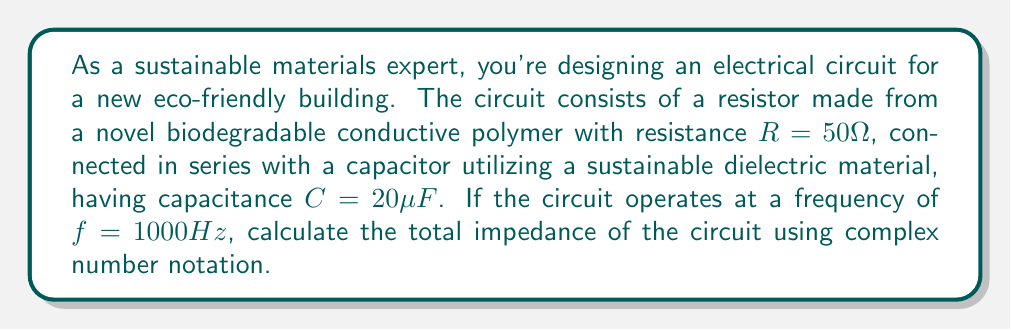Solve this math problem. To solve this problem, we'll follow these steps:

1) First, recall that impedance is a complex number that represents the total opposition to current flow in an AC circuit. It's expressed as $Z = R + jX$, where $R$ is resistance and $X$ is reactance.

2) We're given the resistance $R = 50\Omega$. This will be the real part of our impedance.

3) For the capacitor, we need to calculate its reactance. The formula for capacitive reactance is:

   $X_C = -\frac{1}{2\pi fC}$

4) Let's substitute our values:
   $f = 1000 Hz$
   $C = 20\mu F = 20 \times 10^{-6} F$

   $$X_C = -\frac{1}{2\pi (1000)(20 \times 10^{-6})} = -7957.75\Omega$$

5) Now we have both components of our impedance:
   $R = 50\Omega$
   $X_C = -7957.75\Omega$

6) The total impedance is:
   $Z = R + jX_C = 50 - j7957.75$

7) To express this in polar form (magnitude and angle), we can use:
   $|Z| = \sqrt{R^2 + X_C^2}$
   $\theta = \tan^{-1}(\frac{X_C}{R})$

8) Calculating:
   $|Z| = \sqrt{50^2 + (-7957.75)^2} = 7958.07\Omega$
   $\theta = \tan^{-1}(\frac{-7957.75}{50}) = -89.64°$

Therefore, the total impedance in polar form is $7958.07 \angle -89.64°\Omega$.
Answer: The total impedance of the circuit is $Z = 50 - j7957.75\Omega$ or $7958.07 \angle -89.64°\Omega$. 